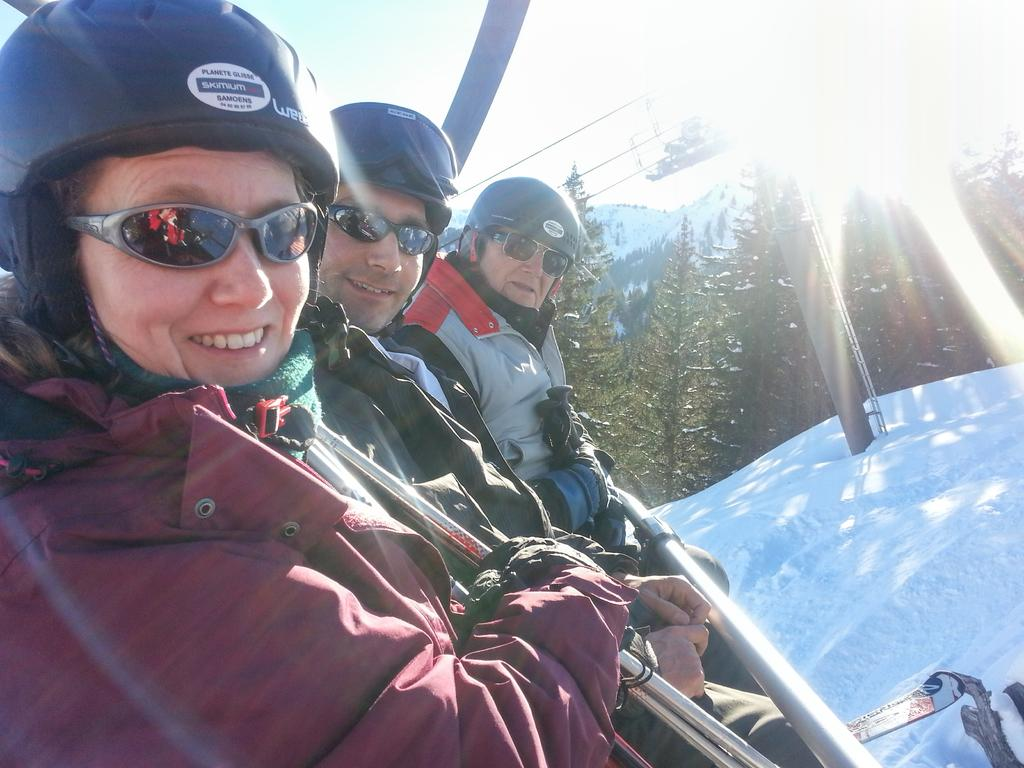How many people are visible on the right side of the image? There are three people on the right side of the image. What can be seen in the background of the image? There are trees and a mountain in the background of the image. What type of surface is present on the bottom right of the image? There is a snow surface on the bottom right of the image. How many mice are hiding behind the trees in the image? There are no mice present in the image; it only features three people, trees, a mountain, and a snow surface. 